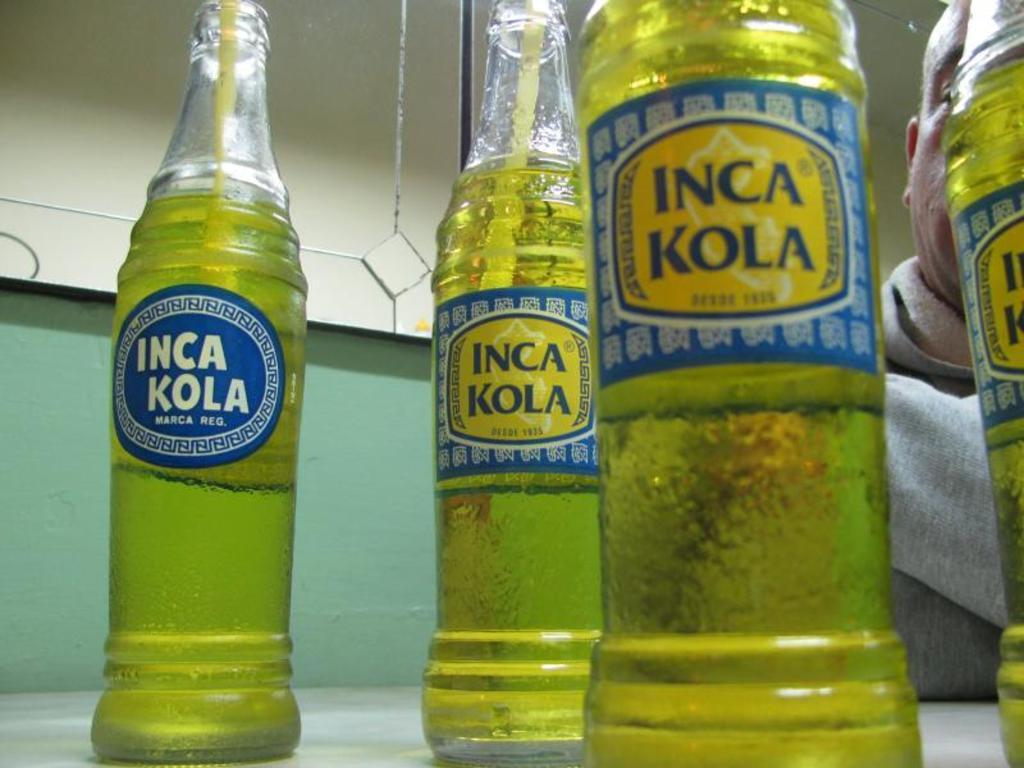Provide a one-sentence caption for the provided image. Four glass bottles with a green drink in them with INCA KOLA on the front. 